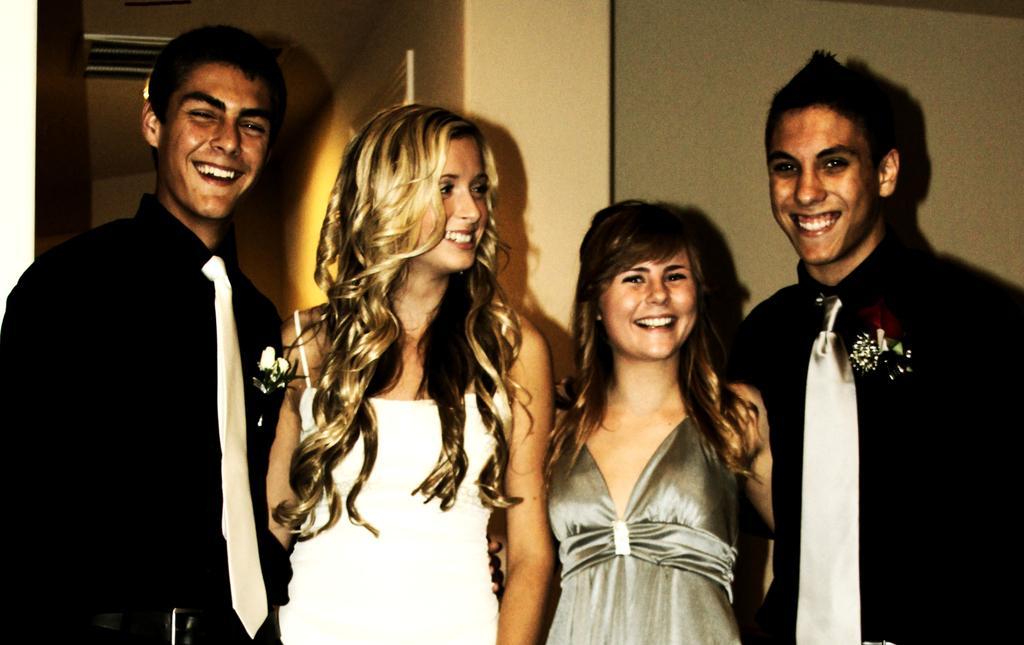How would you summarize this image in a sentence or two? In this image there are two men and two ladies standing, in the background there is a wall. 